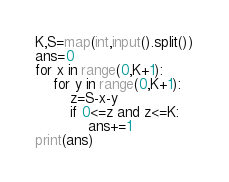<code> <loc_0><loc_0><loc_500><loc_500><_Python_>K,S=map(int,input().split())
ans=0
for x in range(0,K+1):
    for y in range(0,K+1):
        z=S-x-y
        if 0<=z and z<=K:
            ans+=1
print(ans)
</code> 